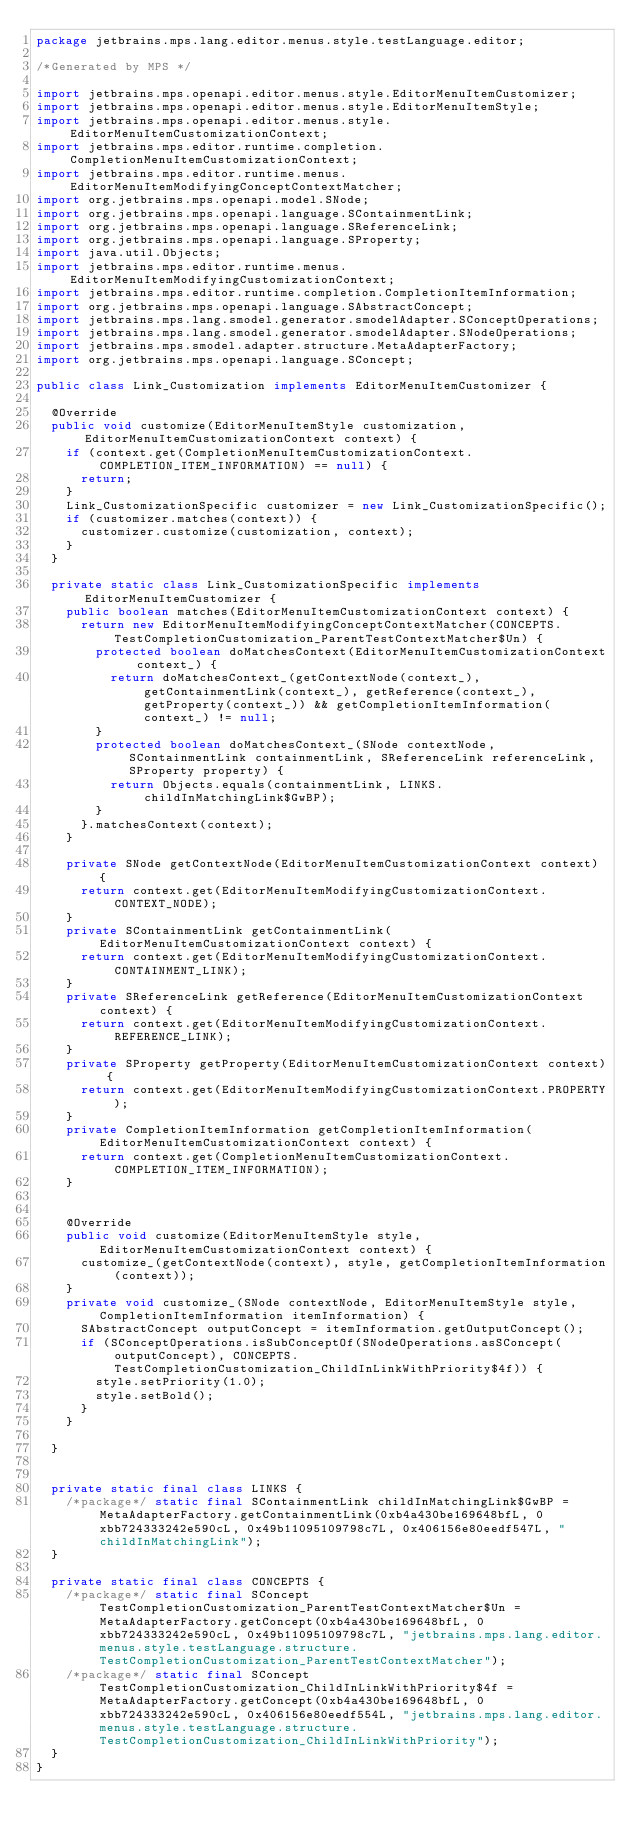Convert code to text. <code><loc_0><loc_0><loc_500><loc_500><_Java_>package jetbrains.mps.lang.editor.menus.style.testLanguage.editor;

/*Generated by MPS */

import jetbrains.mps.openapi.editor.menus.style.EditorMenuItemCustomizer;
import jetbrains.mps.openapi.editor.menus.style.EditorMenuItemStyle;
import jetbrains.mps.openapi.editor.menus.style.EditorMenuItemCustomizationContext;
import jetbrains.mps.editor.runtime.completion.CompletionMenuItemCustomizationContext;
import jetbrains.mps.editor.runtime.menus.EditorMenuItemModifyingConceptContextMatcher;
import org.jetbrains.mps.openapi.model.SNode;
import org.jetbrains.mps.openapi.language.SContainmentLink;
import org.jetbrains.mps.openapi.language.SReferenceLink;
import org.jetbrains.mps.openapi.language.SProperty;
import java.util.Objects;
import jetbrains.mps.editor.runtime.menus.EditorMenuItemModifyingCustomizationContext;
import jetbrains.mps.editor.runtime.completion.CompletionItemInformation;
import org.jetbrains.mps.openapi.language.SAbstractConcept;
import jetbrains.mps.lang.smodel.generator.smodelAdapter.SConceptOperations;
import jetbrains.mps.lang.smodel.generator.smodelAdapter.SNodeOperations;
import jetbrains.mps.smodel.adapter.structure.MetaAdapterFactory;
import org.jetbrains.mps.openapi.language.SConcept;

public class Link_Customization implements EditorMenuItemCustomizer {

  @Override
  public void customize(EditorMenuItemStyle customization, EditorMenuItemCustomizationContext context) {
    if (context.get(CompletionMenuItemCustomizationContext.COMPLETION_ITEM_INFORMATION) == null) {
      return;
    }
    Link_CustomizationSpecific customizer = new Link_CustomizationSpecific();
    if (customizer.matches(context)) {
      customizer.customize(customization, context);
    }
  }

  private static class Link_CustomizationSpecific implements EditorMenuItemCustomizer {
    public boolean matches(EditorMenuItemCustomizationContext context) {
      return new EditorMenuItemModifyingConceptContextMatcher(CONCEPTS.TestCompletionCustomization_ParentTestContextMatcher$Un) {
        protected boolean doMatchesContext(EditorMenuItemCustomizationContext context_) {
          return doMatchesContext_(getContextNode(context_), getContainmentLink(context_), getReference(context_), getProperty(context_)) && getCompletionItemInformation(context_) != null;
        }
        protected boolean doMatchesContext_(SNode contextNode, SContainmentLink containmentLink, SReferenceLink referenceLink, SProperty property) {
          return Objects.equals(containmentLink, LINKS.childInMatchingLink$GwBP);
        }
      }.matchesContext(context);
    }

    private SNode getContextNode(EditorMenuItemCustomizationContext context) {
      return context.get(EditorMenuItemModifyingCustomizationContext.CONTEXT_NODE);
    }
    private SContainmentLink getContainmentLink(EditorMenuItemCustomizationContext context) {
      return context.get(EditorMenuItemModifyingCustomizationContext.CONTAINMENT_LINK);
    }
    private SReferenceLink getReference(EditorMenuItemCustomizationContext context) {
      return context.get(EditorMenuItemModifyingCustomizationContext.REFERENCE_LINK);
    }
    private SProperty getProperty(EditorMenuItemCustomizationContext context) {
      return context.get(EditorMenuItemModifyingCustomizationContext.PROPERTY);
    }
    private CompletionItemInformation getCompletionItemInformation(EditorMenuItemCustomizationContext context) {
      return context.get(CompletionMenuItemCustomizationContext.COMPLETION_ITEM_INFORMATION);
    }


    @Override
    public void customize(EditorMenuItemStyle style, EditorMenuItemCustomizationContext context) {
      customize_(getContextNode(context), style, getCompletionItemInformation(context));
    }
    private void customize_(SNode contextNode, EditorMenuItemStyle style, CompletionItemInformation itemInformation) {
      SAbstractConcept outputConcept = itemInformation.getOutputConcept();
      if (SConceptOperations.isSubConceptOf(SNodeOperations.asSConcept(outputConcept), CONCEPTS.TestCompletionCustomization_ChildInLinkWithPriority$4f)) {
        style.setPriority(1.0);
        style.setBold();
      }
    }

  }


  private static final class LINKS {
    /*package*/ static final SContainmentLink childInMatchingLink$GwBP = MetaAdapterFactory.getContainmentLink(0xb4a430be169648bfL, 0xbb724333242e590cL, 0x49b11095109798c7L, 0x406156e80eedf547L, "childInMatchingLink");
  }

  private static final class CONCEPTS {
    /*package*/ static final SConcept TestCompletionCustomization_ParentTestContextMatcher$Un = MetaAdapterFactory.getConcept(0xb4a430be169648bfL, 0xbb724333242e590cL, 0x49b11095109798c7L, "jetbrains.mps.lang.editor.menus.style.testLanguage.structure.TestCompletionCustomization_ParentTestContextMatcher");
    /*package*/ static final SConcept TestCompletionCustomization_ChildInLinkWithPriority$4f = MetaAdapterFactory.getConcept(0xb4a430be169648bfL, 0xbb724333242e590cL, 0x406156e80eedf554L, "jetbrains.mps.lang.editor.menus.style.testLanguage.structure.TestCompletionCustomization_ChildInLinkWithPriority");
  }
}
</code> 